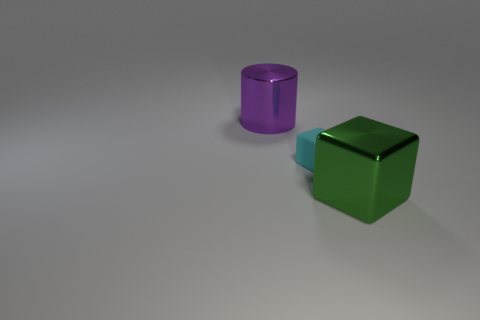What can you say about the lighting in the scene? The lighting in the scene seems to be soft and diffused, coming from above. There are gentle shadows cast by the objects, suggesting the light source is not overly harsh. 